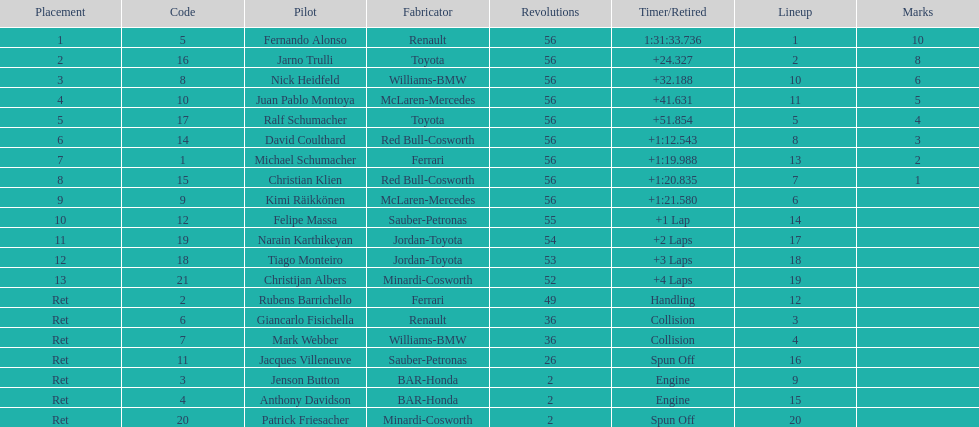How long did it take fernando alonso to finish the race? 1:31:33.736. 